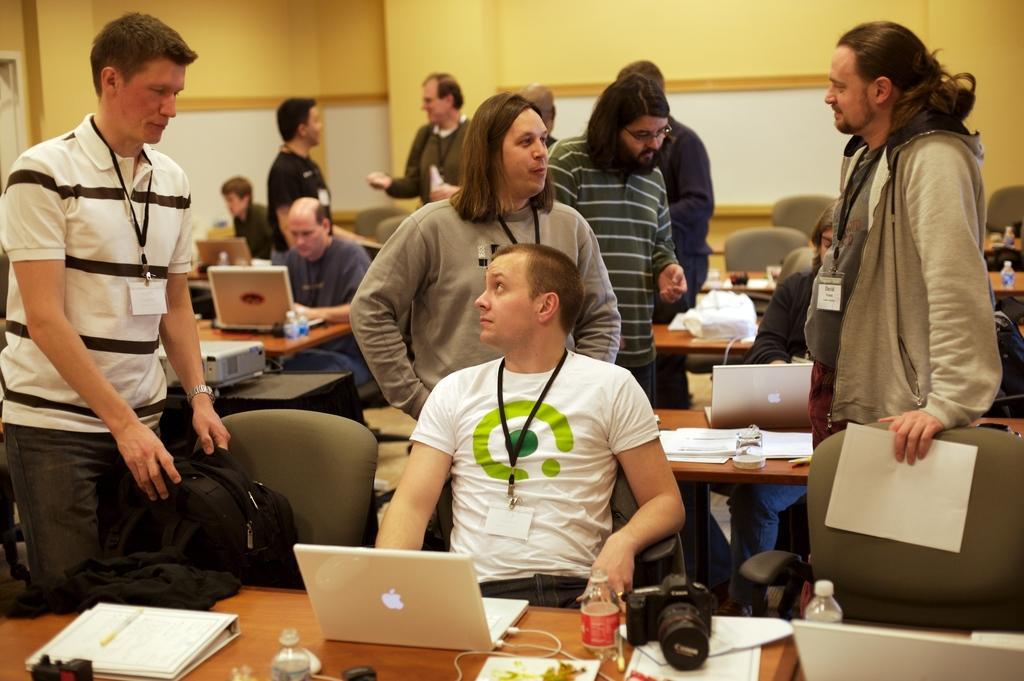Can you describe this image briefly? This picture is clicked inside the room. The man in the middle of the picture wearing white T-shirt is sitting on the chair. In front of him, we see a table on which laptop, files, papers, water bottles and camera are placed. He is looking at the man who is standing beside him. Behind them, we see people are standing. We even see people are sitting on the chairs and in front of them, we see tables on which laptops, papers and water bottles are placed. In the background, we see a yellow color wall. 